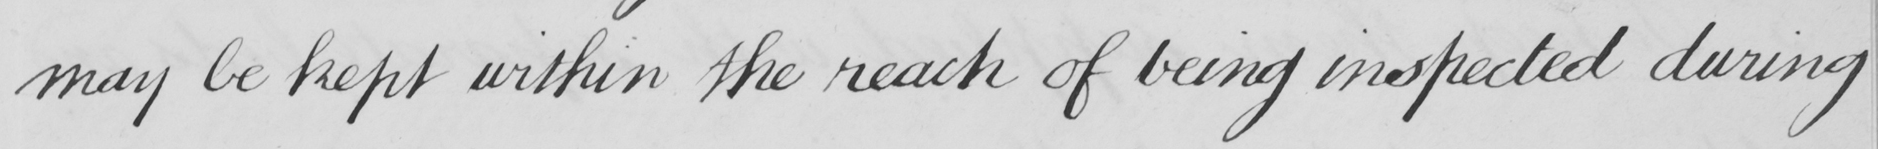What is written in this line of handwriting? may be kept within the reach of being inspected during 